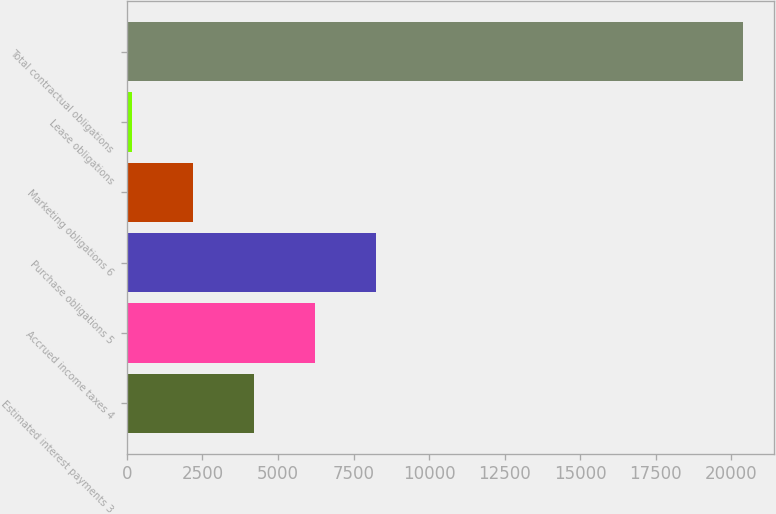<chart> <loc_0><loc_0><loc_500><loc_500><bar_chart><fcel>Estimated interest payments 3<fcel>Accrued income taxes 4<fcel>Purchase obligations 5<fcel>Marketing obligations 6<fcel>Lease obligations<fcel>Total contractual obligations<nl><fcel>4206.4<fcel>6229.1<fcel>8251.8<fcel>2183.7<fcel>161<fcel>20388<nl></chart> 